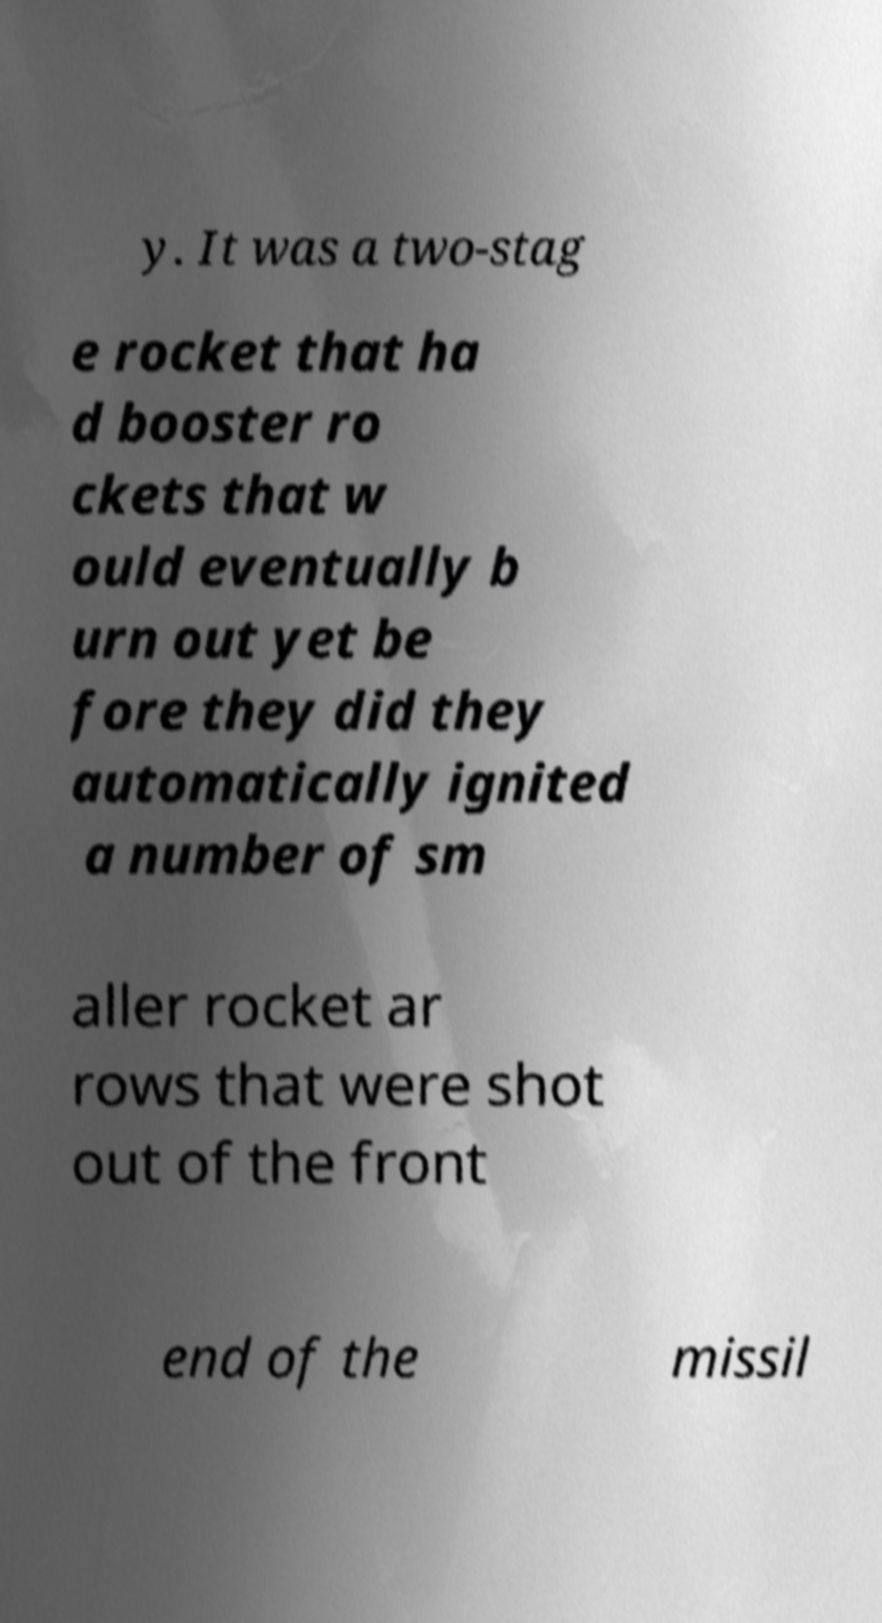Could you extract and type out the text from this image? y. It was a two-stag e rocket that ha d booster ro ckets that w ould eventually b urn out yet be fore they did they automatically ignited a number of sm aller rocket ar rows that were shot out of the front end of the missil 